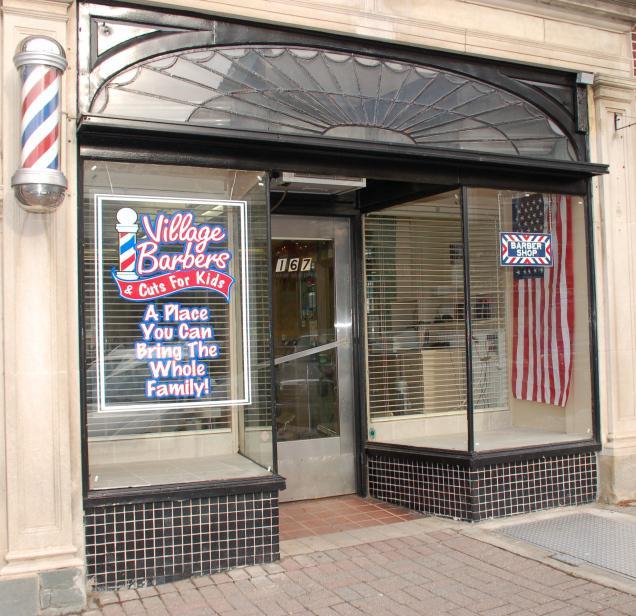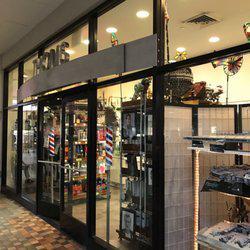The first image is the image on the left, the second image is the image on the right. Given the left and right images, does the statement "There is at least one barber pole in the image on the left." hold true? Answer yes or no. Yes. 